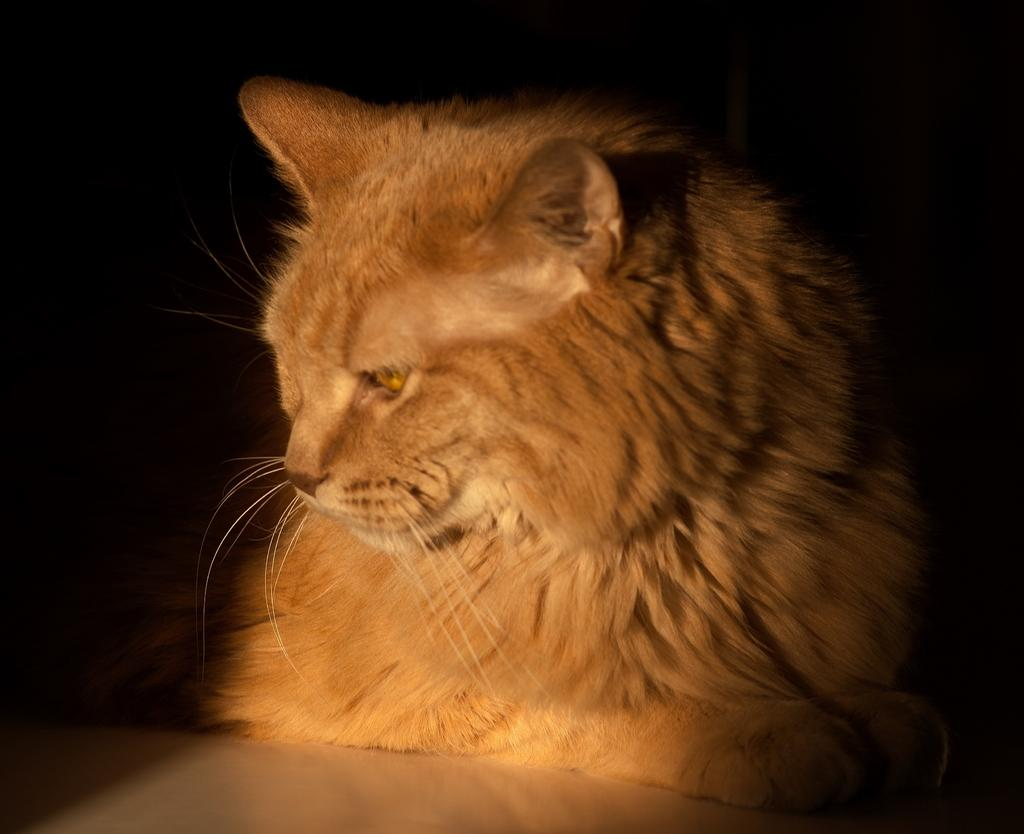What type of animal is in the image? There is a cat in the image. Where is the cat located in the image? The cat is sitting on the floor. What color is the cat? The cat is brown in color. What can be observed about the background of the image? The background of the image is dark. What type of cart is being pulled by the goose in the image? There is no cart or goose present in the image; it features a brown cat sitting on the floor with a dark background. Is there any blood visible in the image? No, there is no blood visible in the image. 